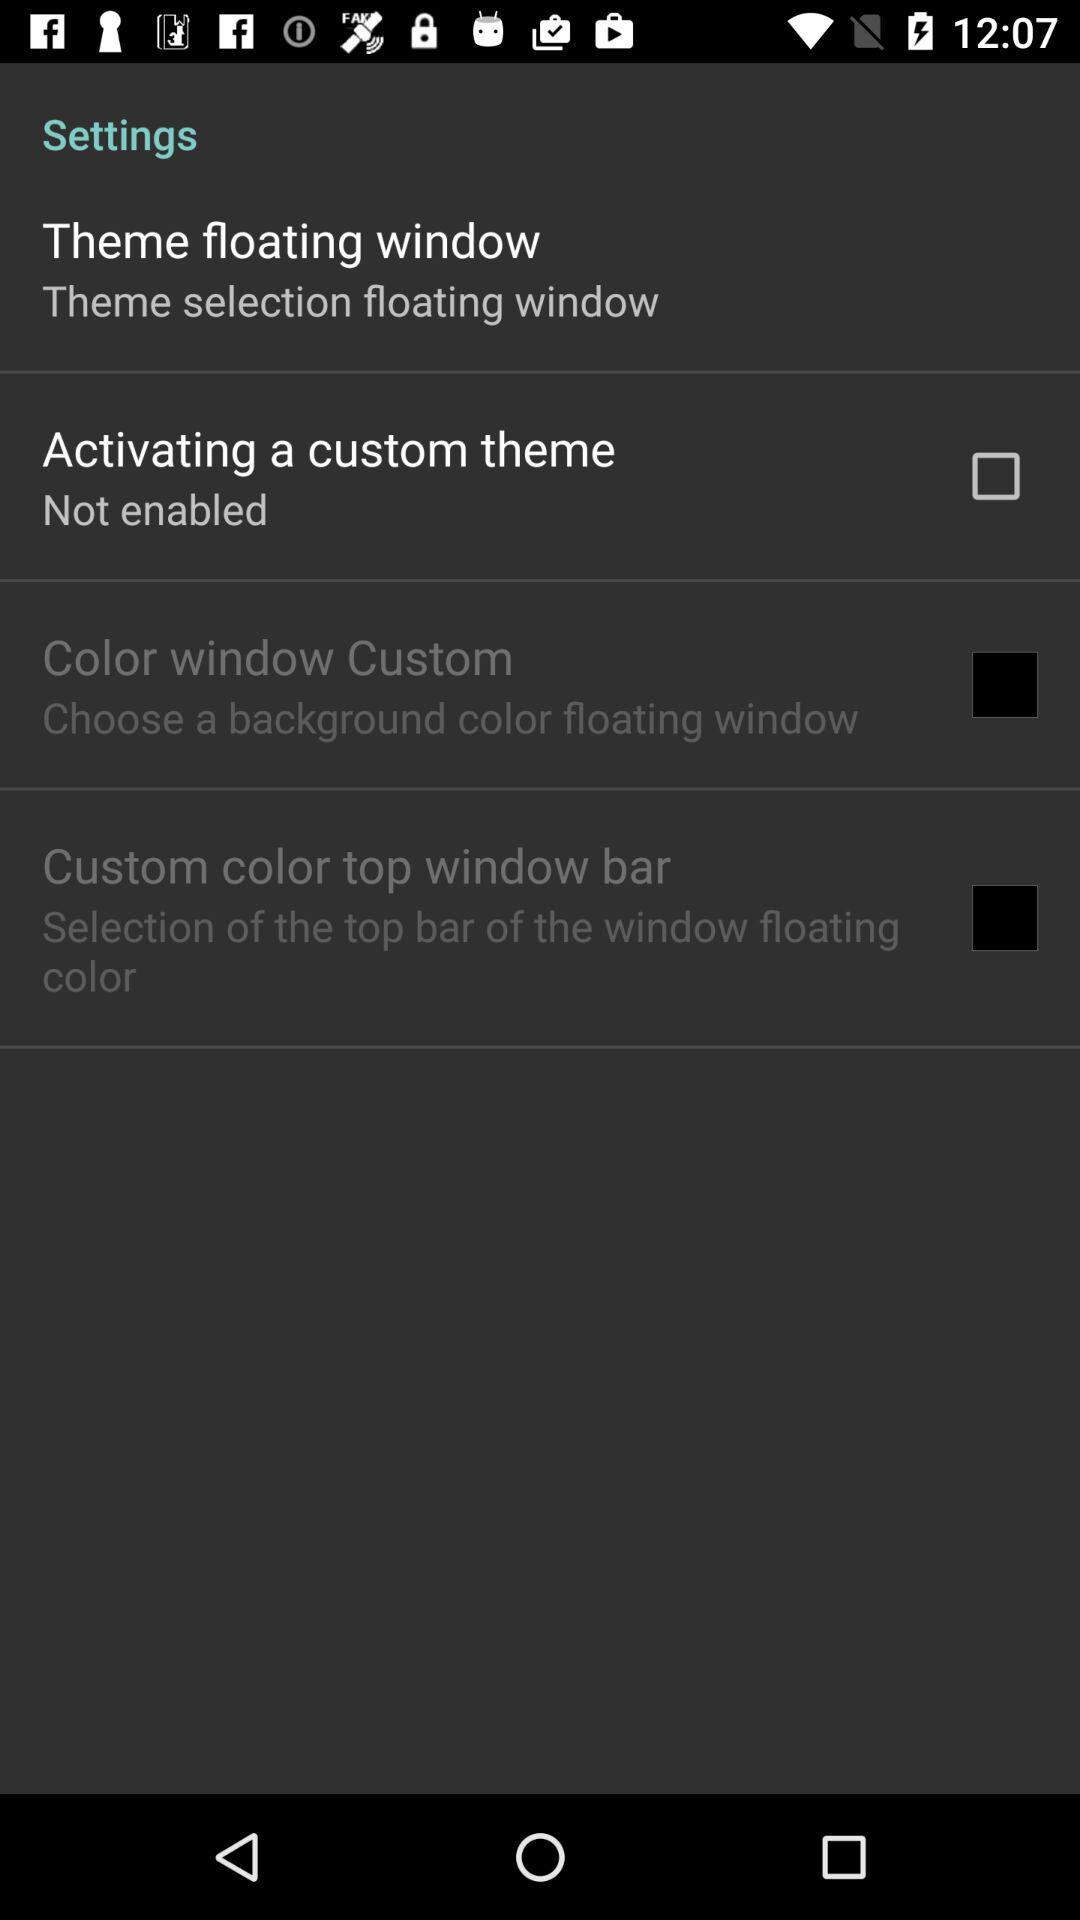What are the available options? The available options are "Theme floating window", "Activating a custom theme", "Color window Custom" and "Custom color top window bar". 